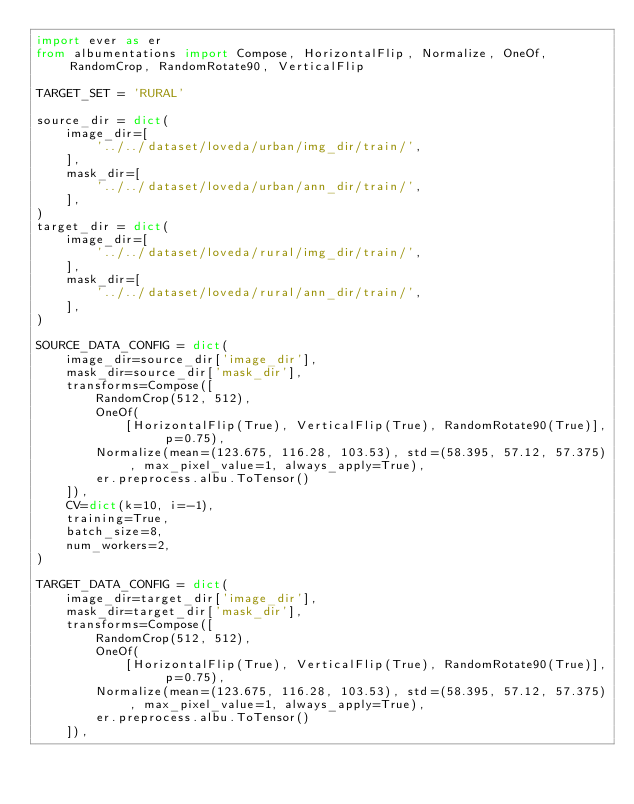<code> <loc_0><loc_0><loc_500><loc_500><_Python_>import ever as er
from albumentations import Compose, HorizontalFlip, Normalize, OneOf, RandomCrop, RandomRotate90, VerticalFlip

TARGET_SET = 'RURAL'

source_dir = dict(
    image_dir=[
        '../../dataset/loveda/urban/img_dir/train/',
    ],
    mask_dir=[
        '../../dataset/loveda/urban/ann_dir/train/',
    ],
)
target_dir = dict(
    image_dir=[
        '../../dataset/loveda/rural/img_dir/train/',
    ],
    mask_dir=[
        '../../dataset/loveda/rural/ann_dir/train/',
    ],
)

SOURCE_DATA_CONFIG = dict(
    image_dir=source_dir['image_dir'],
    mask_dir=source_dir['mask_dir'],
    transforms=Compose([
        RandomCrop(512, 512),
        OneOf(
            [HorizontalFlip(True), VerticalFlip(True), RandomRotate90(True)], p=0.75),
        Normalize(mean=(123.675, 116.28, 103.53), std=(58.395, 57.12, 57.375), max_pixel_value=1, always_apply=True),
        er.preprocess.albu.ToTensor()
    ]),
    CV=dict(k=10, i=-1),
    training=True,
    batch_size=8,
    num_workers=2,
)

TARGET_DATA_CONFIG = dict(
    image_dir=target_dir['image_dir'],
    mask_dir=target_dir['mask_dir'],
    transforms=Compose([
        RandomCrop(512, 512),
        OneOf(
            [HorizontalFlip(True), VerticalFlip(True), RandomRotate90(True)], p=0.75),
        Normalize(mean=(123.675, 116.28, 103.53), std=(58.395, 57.12, 57.375), max_pixel_value=1, always_apply=True),
        er.preprocess.albu.ToTensor()
    ]),</code> 